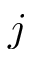<formula> <loc_0><loc_0><loc_500><loc_500>j</formula> 